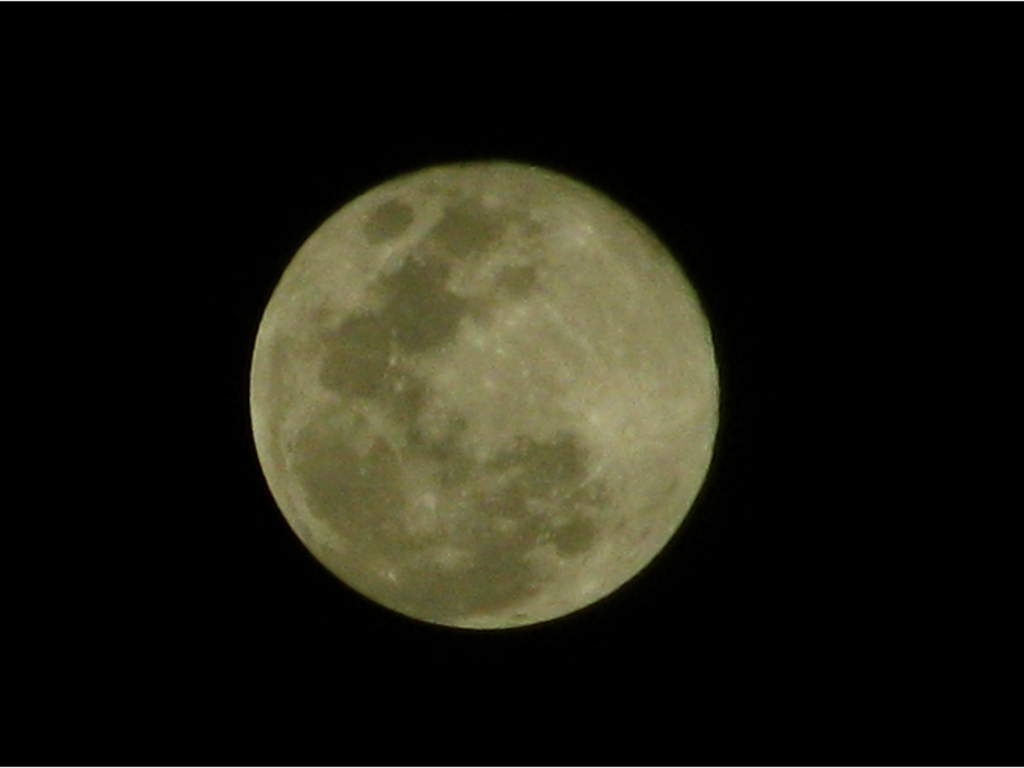How do scientists study the surface of the moon from Earth? Scientists study the moon's surface through telescopes equipped with high-resolution cameras and spectrometers. These tools help them to map the moon's topography, analyze the composition of its soil, and track changes over time. Some research also uses data obtained from lunar missions and orbiting spacecraft, which provide detailed imagery and samples for study. What kind of missions have been sent to the moon? Numerous missions have been sent to the moon, ranging from the historic Apollo manned landings that brought back lunar samples, to recent robotic missions like NASA's Lunar Reconnaissance Orbiter which maps the surface in high detail. Other countries have also sent exploratory missions, like China's Chang'e series, which includes orbiters, landers, and rovers. 